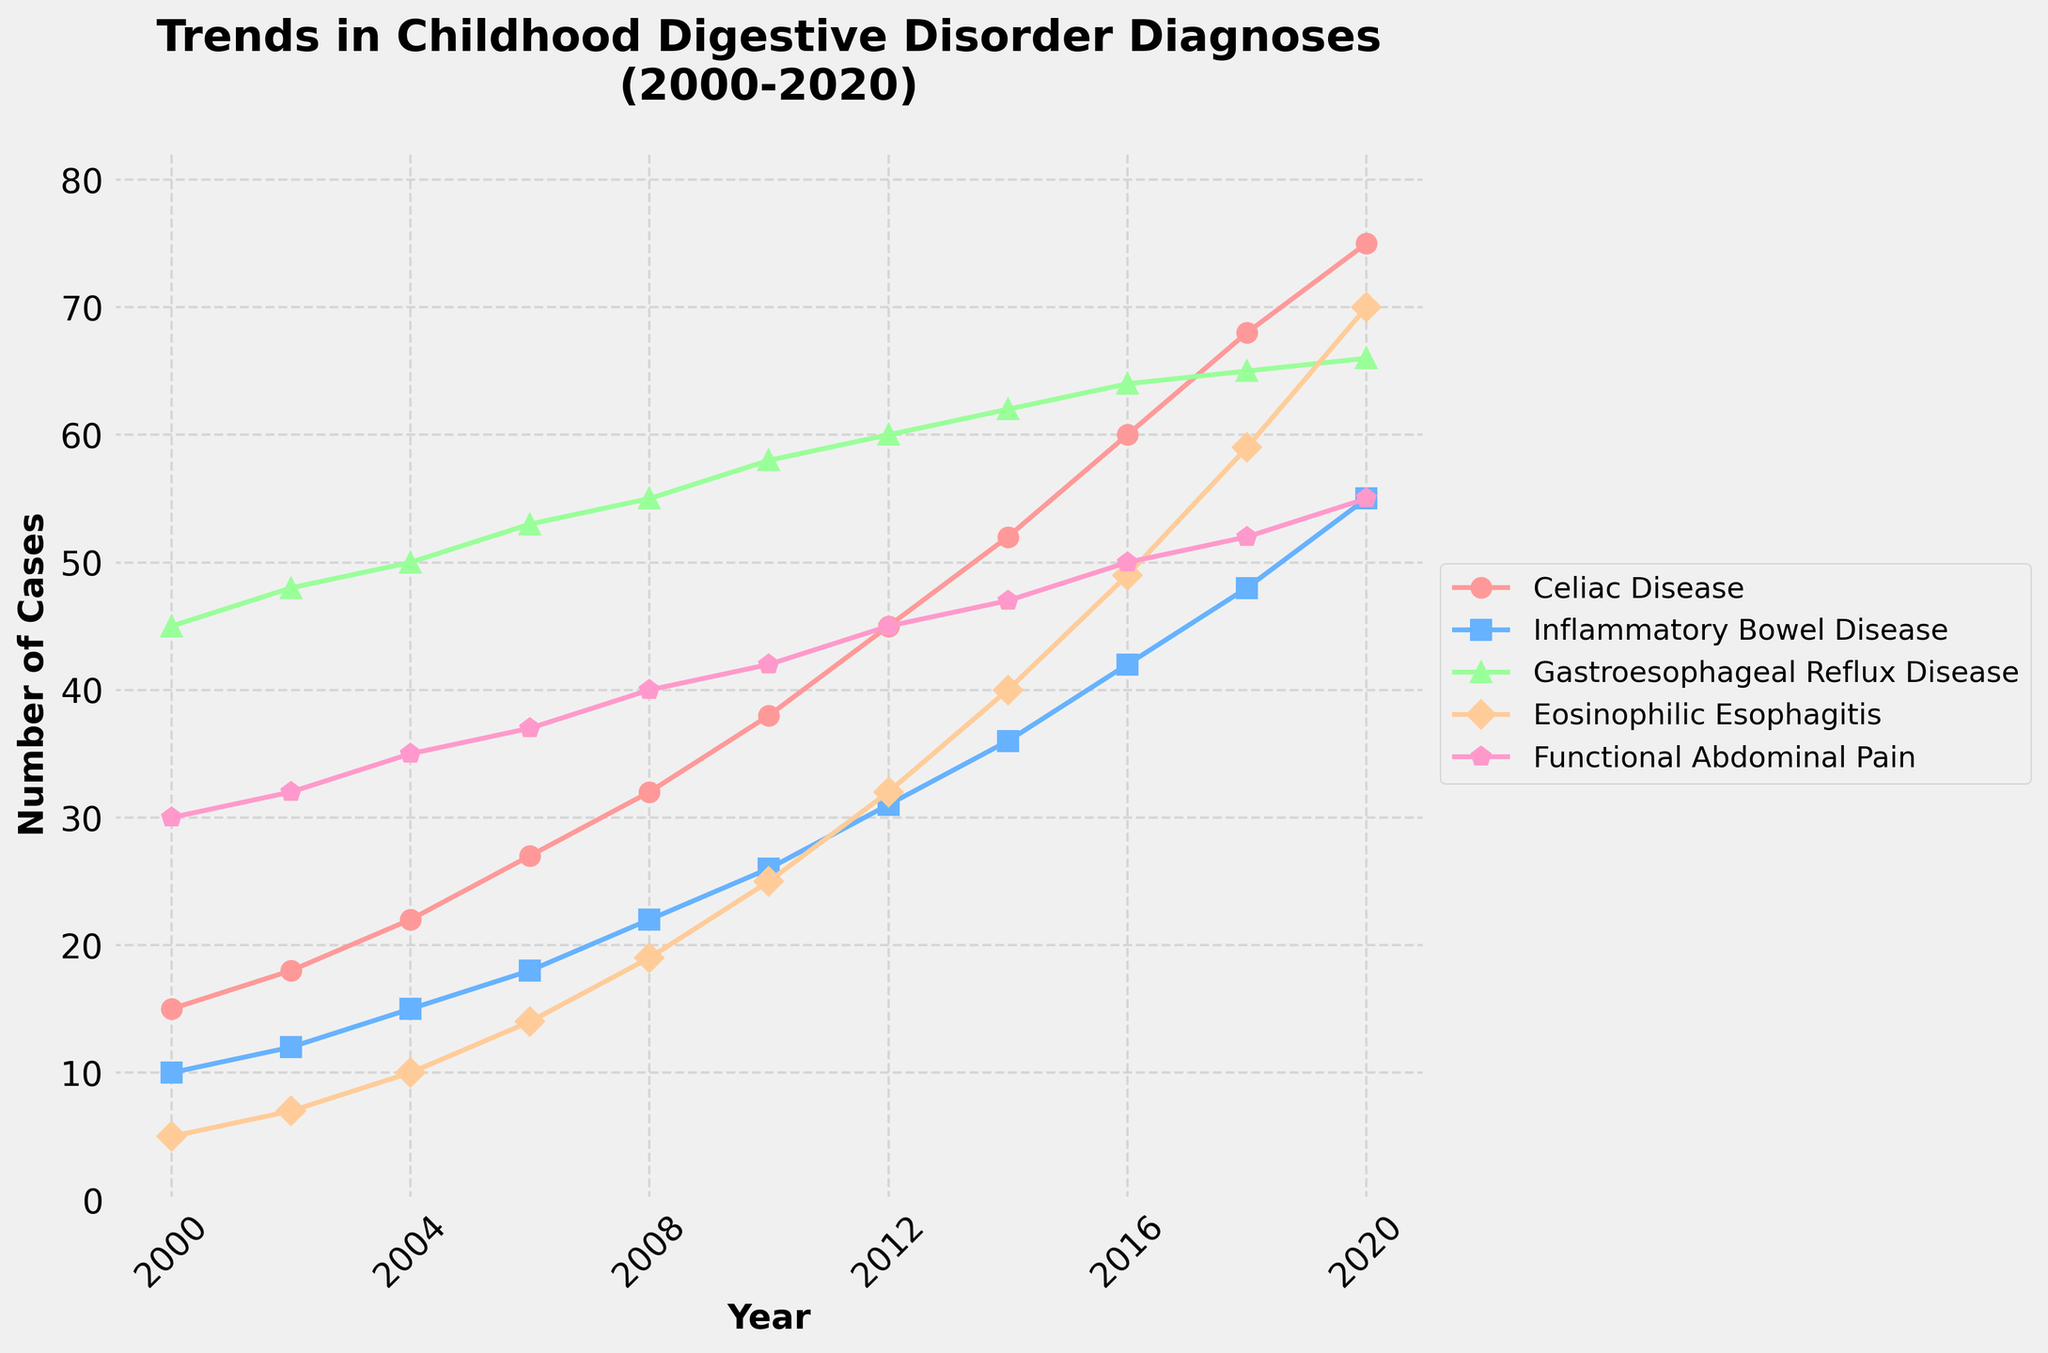What year did Celiac Disease surpass 50 cases? Looking at the Celiac Disease line, the figure shows it surpasses 50 cases in 2014.
Answer: 2014 Which digestive disorder had the highest number of diagnoses in 2020? In 2020, the Gastroesophageal Reflux Disease (GERD) line reaches the highest point compared to other conditions.
Answer: Gastroesophageal Reflux Disease What is the difference in the number of cases of Inflammatory Bowel Disease between 2004 and 2018? In 2004, there were 15 cases of Inflammatory Bowel Disease; in 2018, there were 48. The difference is 48 - 15 = 33.
Answer: 33 Which condition showed the steepest increase between 2010 and 2020? Both the Celiac Disease and Eosinophilic Esophagitis lines show notable increases, but the Eosinophilic Esophagitis line has a steeper slope, rising from 25 to 70 cases.
Answer: Eosinophilic Esophagitis How many conditions had diagnoses fewer than 50 cases in 2016? In 2016, the Celiac Disease, Inflammatory Bowel Disease, Gastroesophageal Reflux Disease, and Functional Abdominal Pain lines all have more than 50 cases. Only Eosinophilic Esophagitis has fewer than 50.
Answer: One condition Which year shows the first overlap between Inflammatory Bowel Disease and Functional Abdominal Pain? These lines first cross each other in 2016 when both conditions report 50 cases.
Answer: 2016 What is the average number of cases of Functional Abdominal Pain across all years? Summing the Functional Abdominal Pain cases (30, 32, 35, 37, 40, 42, 45, 47, 50, 52, 55) and dividing by 11: (30 + 32 + 35 + 37 + 40 + 42 + 45 + 47 + 50 + 52 + 55) / 11 = 42.18.
Answer: 42.18 Which condition had the least cases in 2008? In 2008, Eosinophilic Esophagitis had the fewest cases with 19.
Answer: Eosinophilic Esophagitis By how much did Celiac Disease diagnoses increase between 2000 and 2012? Celiac Disease starts with 15 cases in 2000 and reaches 45 in 2012. The increase is 45 - 15 = 30.
Answer: 30 What is the trend for Gastroesophageal Reflux Disease diagnoses from 2000 to 2020? Consistently increasing trend, starting from 45 cases in 2000 and reaching 66 cases in 2020.
Answer: Increasing Trend 